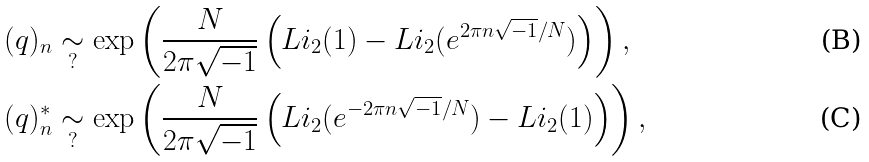<formula> <loc_0><loc_0><loc_500><loc_500>( q ) _ { n } & \underset { ? } { \sim } \exp \left ( \frac { N } { 2 \pi \sqrt { - 1 } } \left ( L i _ { 2 } ( 1 ) - L i _ { 2 } ( e ^ { 2 \pi n \sqrt { - 1 } / N } ) \right ) \right ) , \\ ( q ) _ { n } ^ { \ast } & \underset { ? } { \sim } \exp \left ( \frac { N } { 2 \pi \sqrt { - 1 } } \left ( L i _ { 2 } ( e ^ { - 2 \pi n \sqrt { - 1 } / N } ) - L i _ { 2 } ( 1 ) \right ) \right ) ,</formula> 